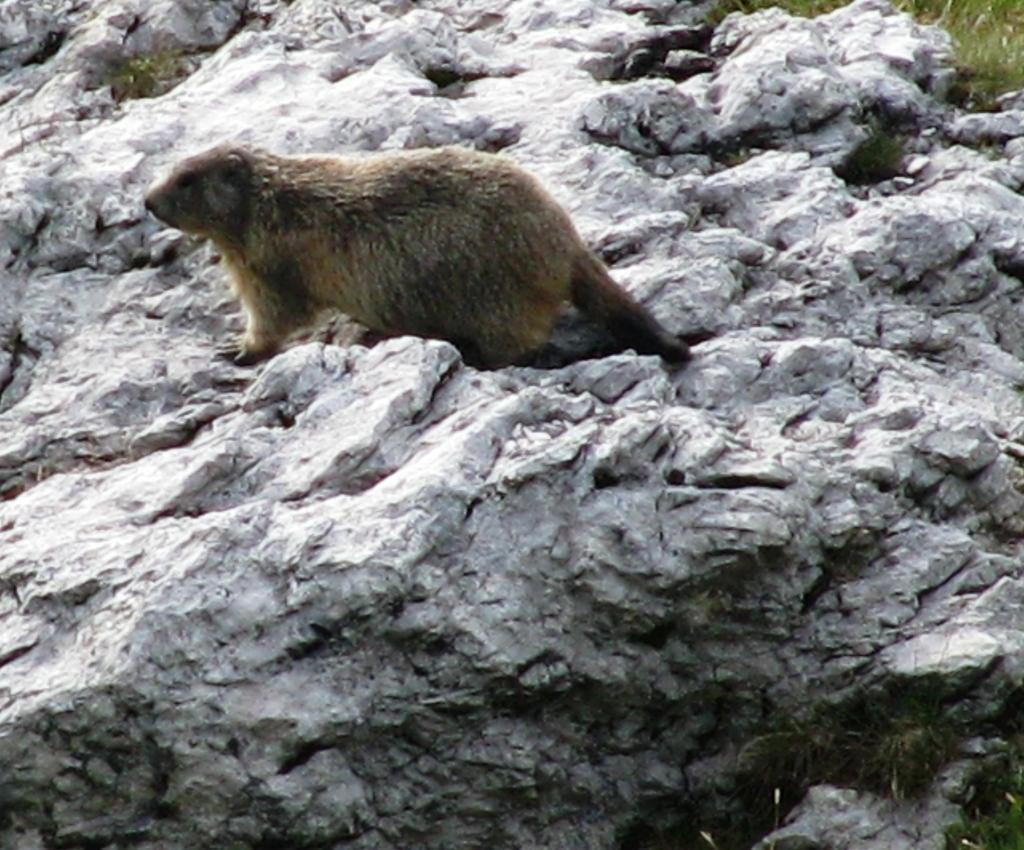Please provide a concise description of this image. In this image, we can see an animal on the rock, we can see the grass on the right side top. 